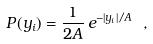<formula> <loc_0><loc_0><loc_500><loc_500>P ( y _ { i } ) = \frac { 1 } { 2 A } \, e ^ { - | y _ { i } | / A } \ ,</formula> 